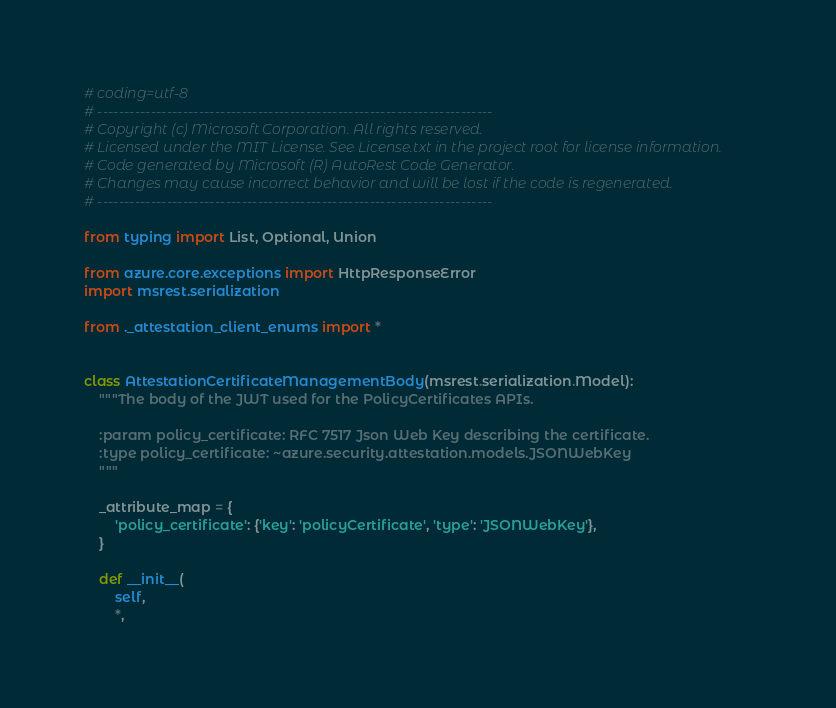<code> <loc_0><loc_0><loc_500><loc_500><_Python_># coding=utf-8
# --------------------------------------------------------------------------
# Copyright (c) Microsoft Corporation. All rights reserved.
# Licensed under the MIT License. See License.txt in the project root for license information.
# Code generated by Microsoft (R) AutoRest Code Generator.
# Changes may cause incorrect behavior and will be lost if the code is regenerated.
# --------------------------------------------------------------------------

from typing import List, Optional, Union

from azure.core.exceptions import HttpResponseError
import msrest.serialization

from ._attestation_client_enums import *


class AttestationCertificateManagementBody(msrest.serialization.Model):
    """The body of the JWT used for the PolicyCertificates APIs.

    :param policy_certificate: RFC 7517 Json Web Key describing the certificate.
    :type policy_certificate: ~azure.security.attestation.models.JSONWebKey
    """

    _attribute_map = {
        'policy_certificate': {'key': 'policyCertificate', 'type': 'JSONWebKey'},
    }

    def __init__(
        self,
        *,</code> 